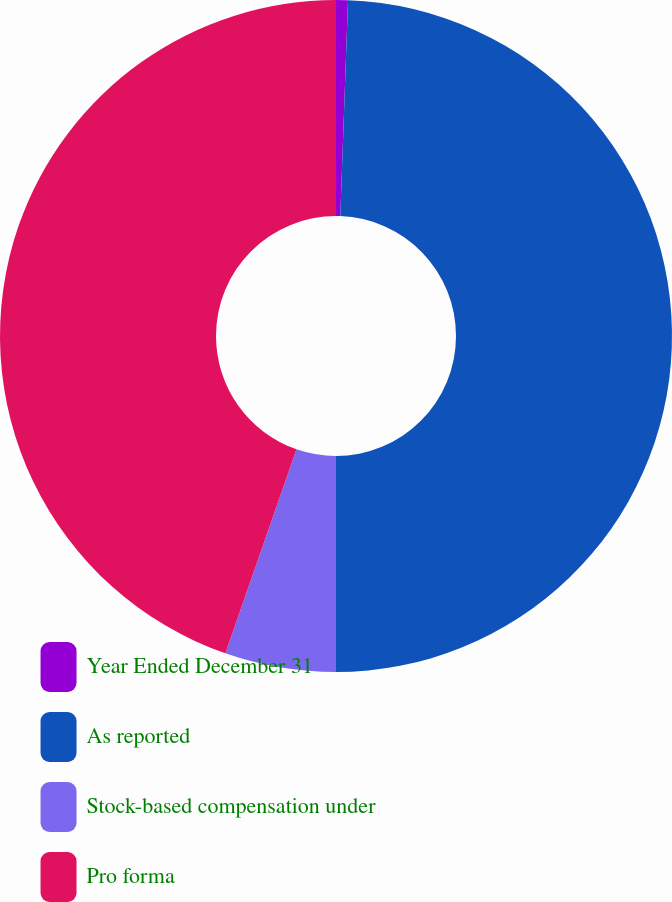Convert chart to OTSL. <chart><loc_0><loc_0><loc_500><loc_500><pie_chart><fcel>Year Ended December 31<fcel>As reported<fcel>Stock-based compensation under<fcel>Pro forma<nl><fcel>0.57%<fcel>49.43%<fcel>5.34%<fcel>44.66%<nl></chart> 